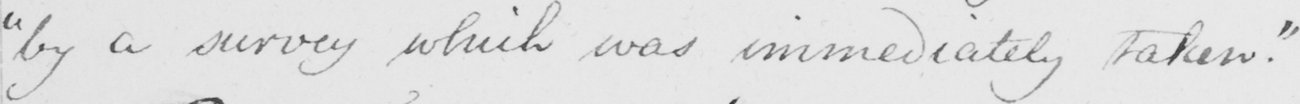What text is written in this handwritten line? " by a survey which was immediately taken . " 